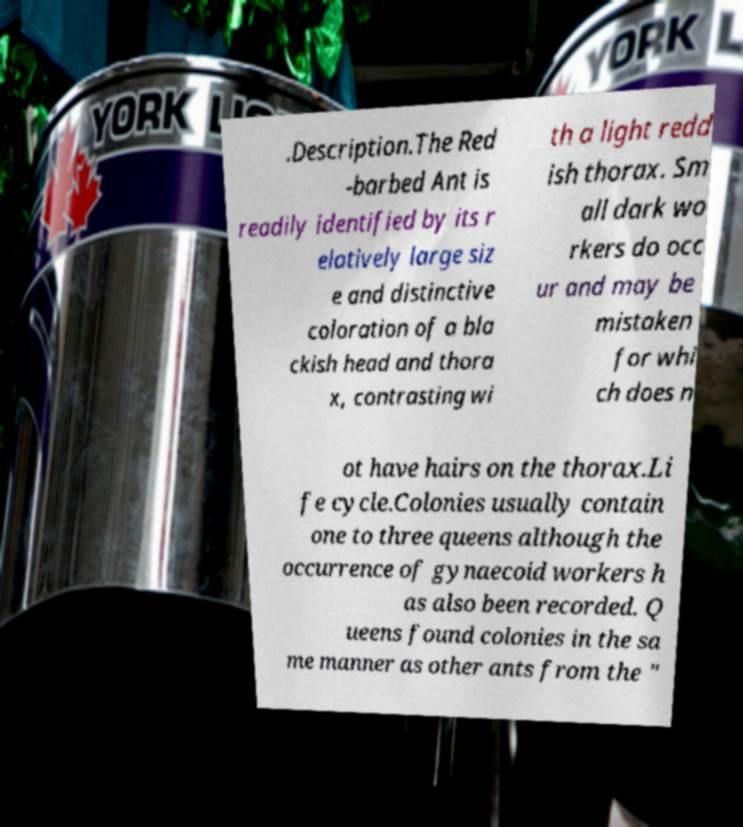For documentation purposes, I need the text within this image transcribed. Could you provide that? .Description.The Red -barbed Ant is readily identified by its r elatively large siz e and distinctive coloration of a bla ckish head and thora x, contrasting wi th a light redd ish thorax. Sm all dark wo rkers do occ ur and may be mistaken for whi ch does n ot have hairs on the thorax.Li fe cycle.Colonies usually contain one to three queens although the occurrence of gynaecoid workers h as also been recorded. Q ueens found colonies in the sa me manner as other ants from the " 